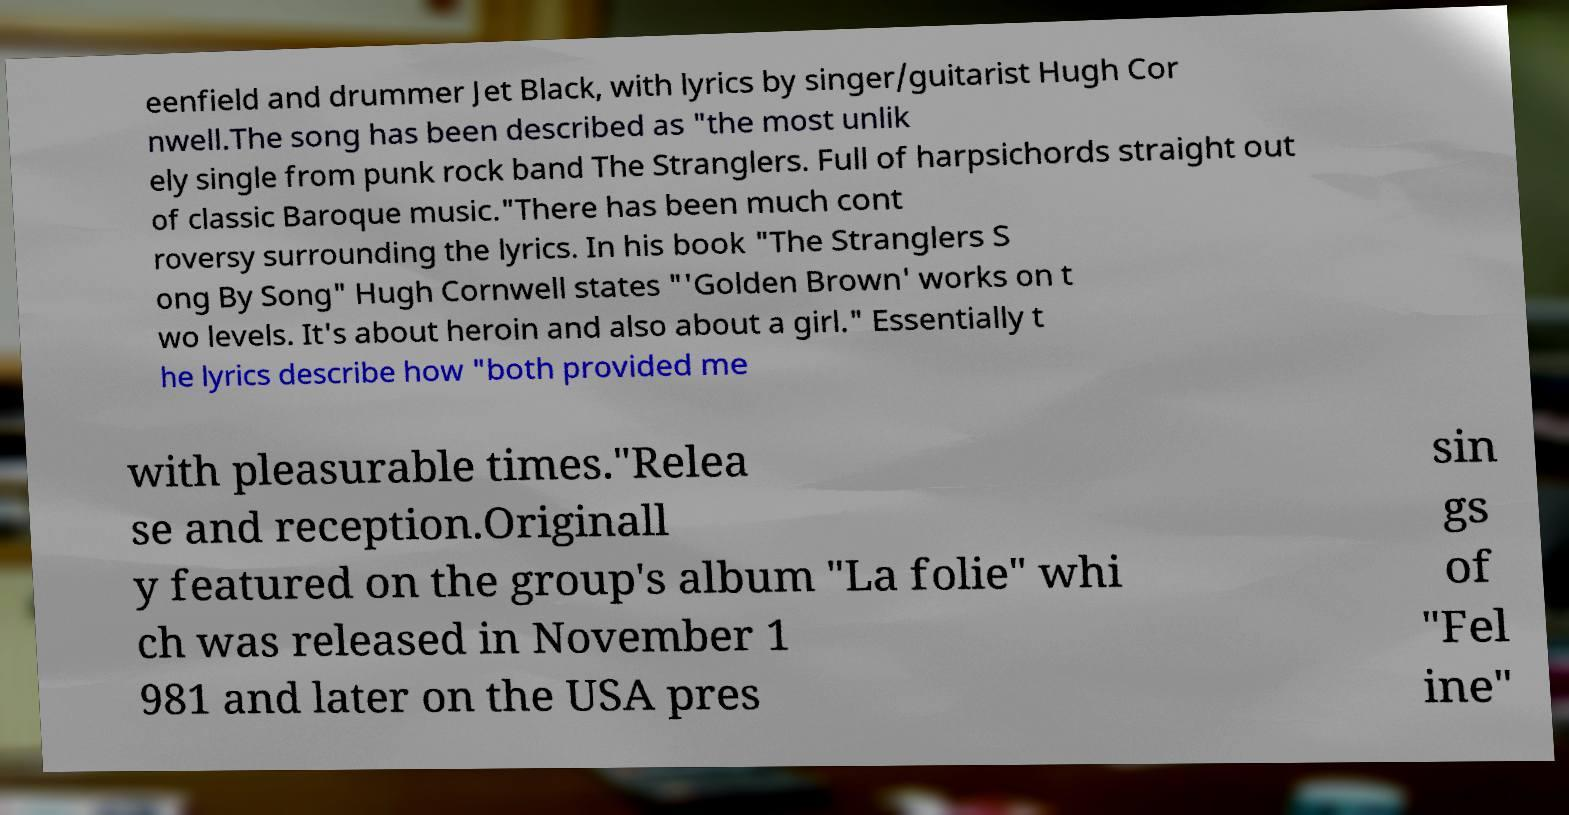Could you assist in decoding the text presented in this image and type it out clearly? eenfield and drummer Jet Black, with lyrics by singer/guitarist Hugh Cor nwell.The song has been described as "the most unlik ely single from punk rock band The Stranglers. Full of harpsichords straight out of classic Baroque music."There has been much cont roversy surrounding the lyrics. In his book "The Stranglers S ong By Song" Hugh Cornwell states "'Golden Brown' works on t wo levels. It's about heroin and also about a girl." Essentially t he lyrics describe how "both provided me with pleasurable times."Relea se and reception.Originall y featured on the group's album "La folie" whi ch was released in November 1 981 and later on the USA pres sin gs of "Fel ine" 